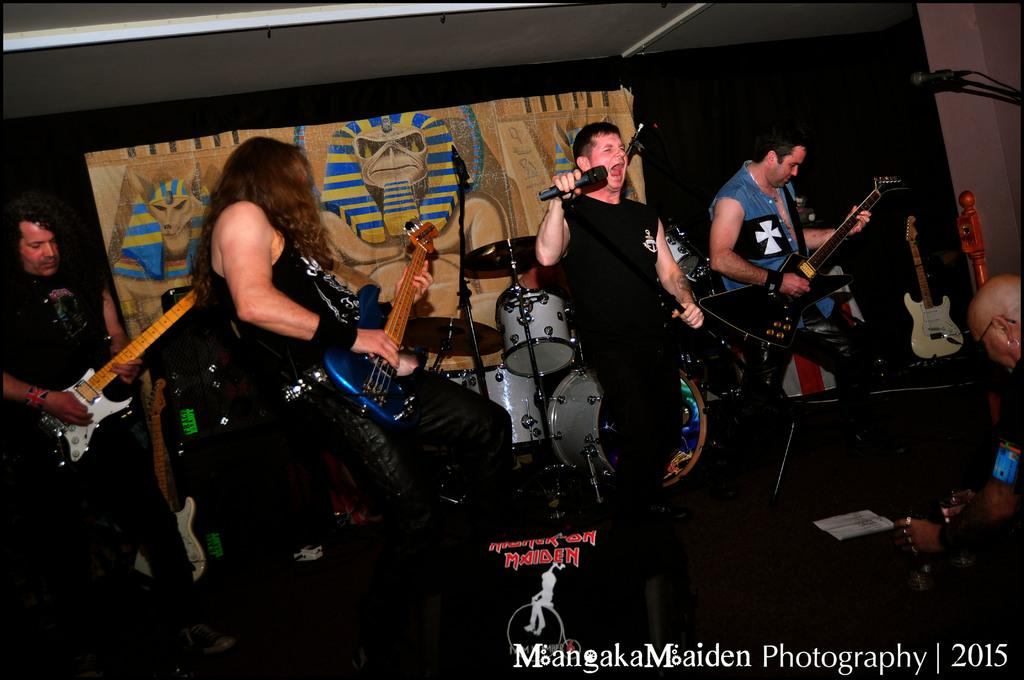How many people are in the image? There are four persons in the image. What are the persons doing in the image? The persons are standing and holding guitars. Can you describe the person in the center? The center person is holding a microphone. What can be seen in the background of the image? There is a banner and a wall in the background of the image. What else is present in the background of the image? There are guitars in the background of the image. What type of trees can be seen in the background of the image? There are no trees visible in the background of the image. What scent is associated with the mine in the image? There is no mine present in the image, so it is not possible to determine any associated scent. 